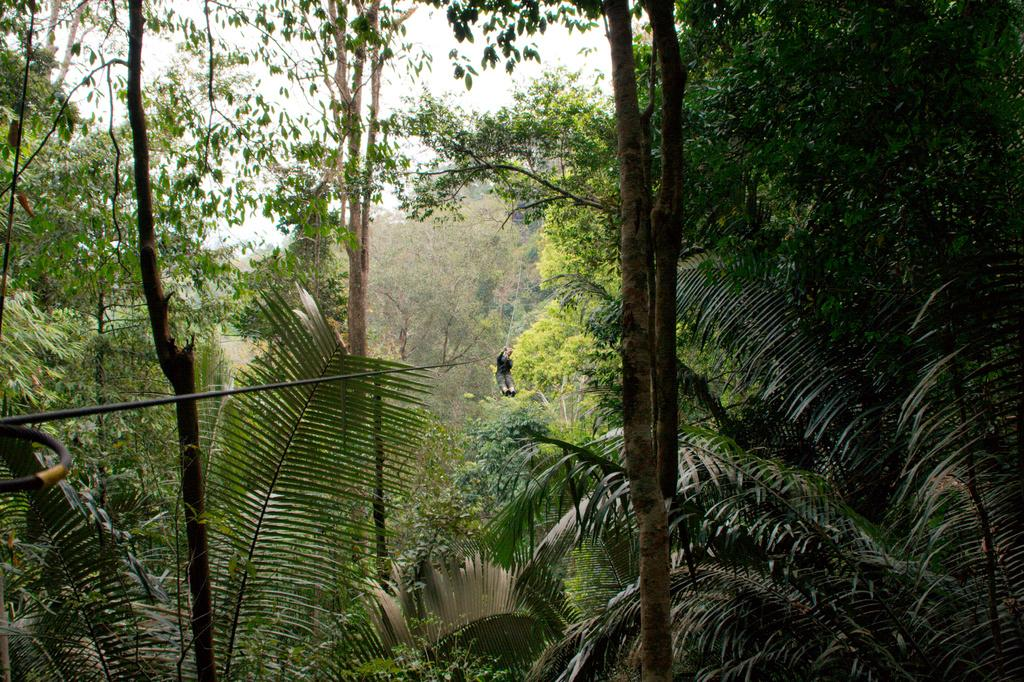What is the man in the image doing? The man is doing rappelling in the image. What can be seen in the background of the image? There are trees in the background of the image. Where might this image have been taken? The image might have been taken in a forest, given the presence of trees in the background. What color are the man's eyes in the image? The image does not provide enough detail to determine the color of the man's eyes. What is the man using to carry water in the image? There is no pail or any object used for carrying water present in the image. 